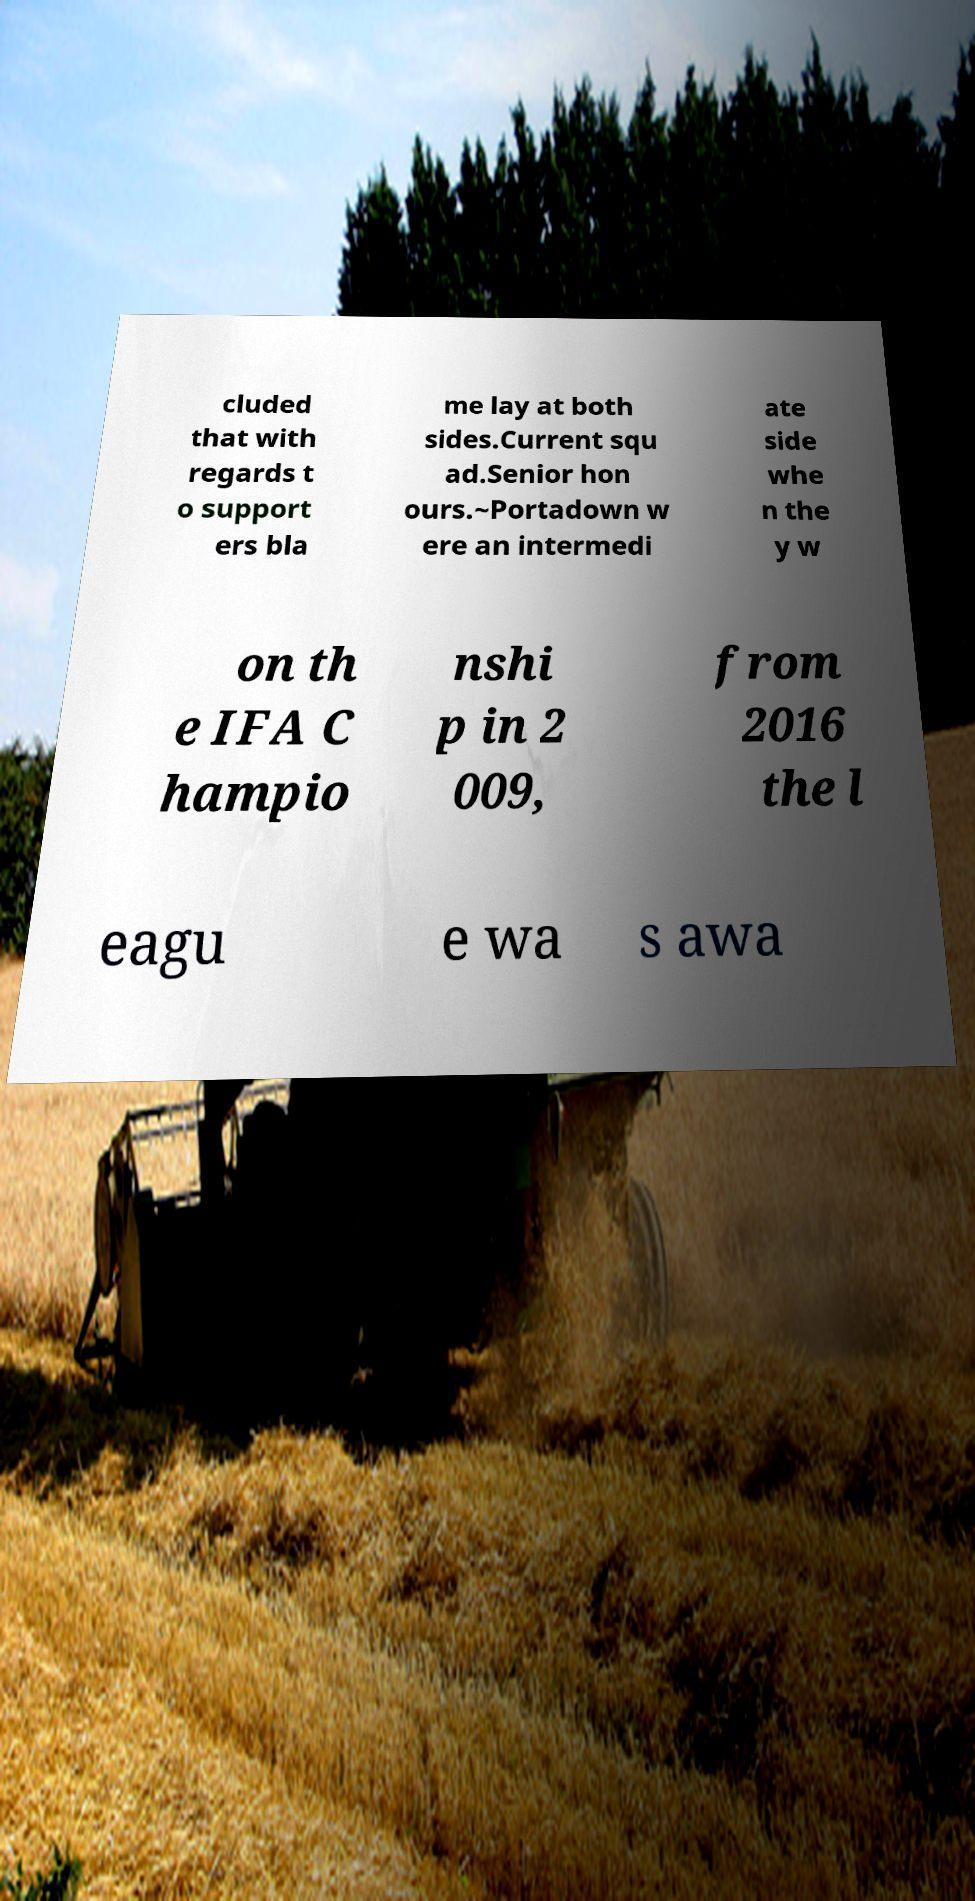What messages or text are displayed in this image? I need them in a readable, typed format. cluded that with regards t o support ers bla me lay at both sides.Current squ ad.Senior hon ours.~Portadown w ere an intermedi ate side whe n the y w on th e IFA C hampio nshi p in 2 009, from 2016 the l eagu e wa s awa 